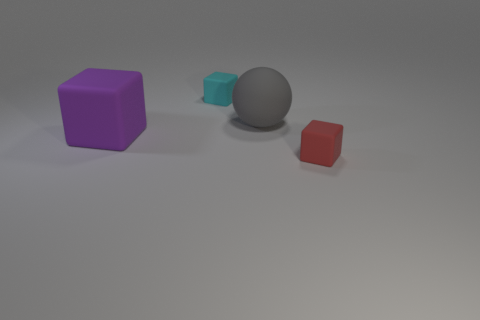Add 4 large gray metal cubes. How many objects exist? 8 Subtract all cubes. How many objects are left? 1 Add 4 small green matte spheres. How many small green matte spheres exist? 4 Subtract 0 brown cubes. How many objects are left? 4 Subtract all tiny matte blocks. Subtract all small matte cubes. How many objects are left? 0 Add 4 rubber objects. How many rubber objects are left? 8 